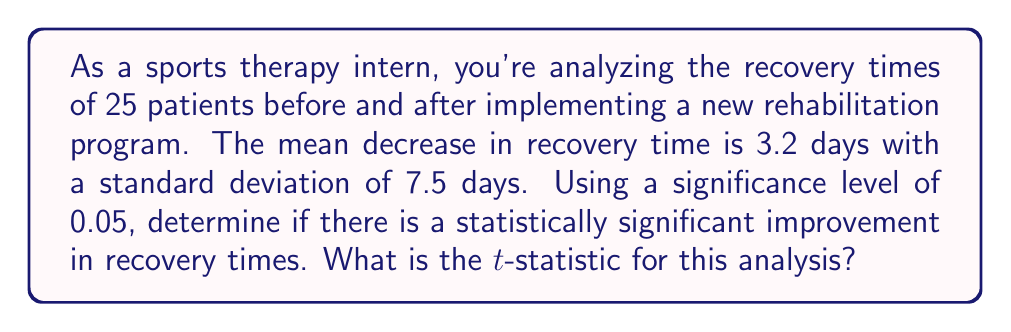What is the answer to this math problem? To determine if there's a statistically significant improvement in recovery times, we'll use a one-sample t-test. We'll calculate the t-statistic and compare it to the critical value.

Step 1: Identify the given information
- Sample size: $n = 25$
- Mean decrease in recovery time: $\bar{x} = 3.2$ days
- Standard deviation: $s = 7.5$ days
- Significance level: $\alpha = 0.05$
- Null hypothesis: $H_0: \mu = 0$ (no improvement)
- Alternative hypothesis: $H_a: \mu > 0$ (improvement)

Step 2: Calculate the standard error of the mean
$SE = \frac{s}{\sqrt{n}} = \frac{7.5}{\sqrt{25}} = 1.5$

Step 3: Calculate the t-statistic
The t-statistic formula is:
$$t = \frac{\bar{x} - \mu_0}{SE}$$

Where $\mu_0 = 0$ (null hypothesis value)

$$t = \frac{3.2 - 0}{1.5} = 2.133$$

Step 4: Interpretation
The calculated t-statistic is 2.133. To determine statistical significance, we would compare this to the critical value from a t-distribution table with 24 degrees of freedom (n-1) and α = 0.05 for a one-tailed test. However, the question only asks for the t-statistic calculation.
Answer: 2.133 